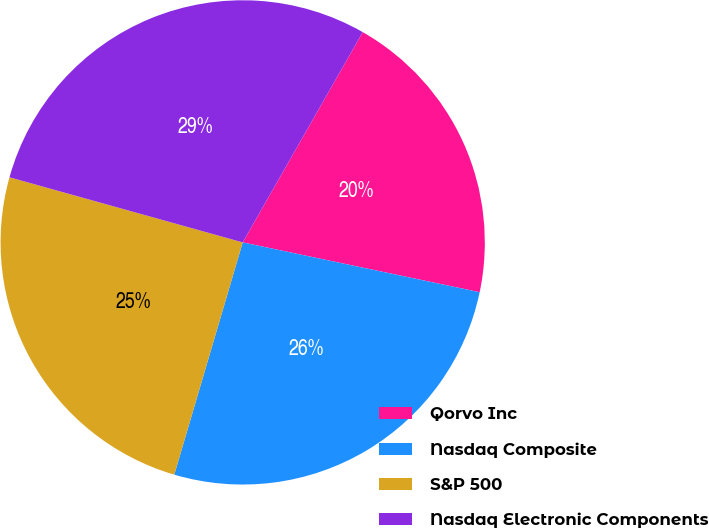Convert chart. <chart><loc_0><loc_0><loc_500><loc_500><pie_chart><fcel>Qorvo Inc<fcel>Nasdaq Composite<fcel>S&P 500<fcel>Nasdaq Electronic Components<nl><fcel>20.04%<fcel>26.26%<fcel>24.77%<fcel>28.92%<nl></chart> 